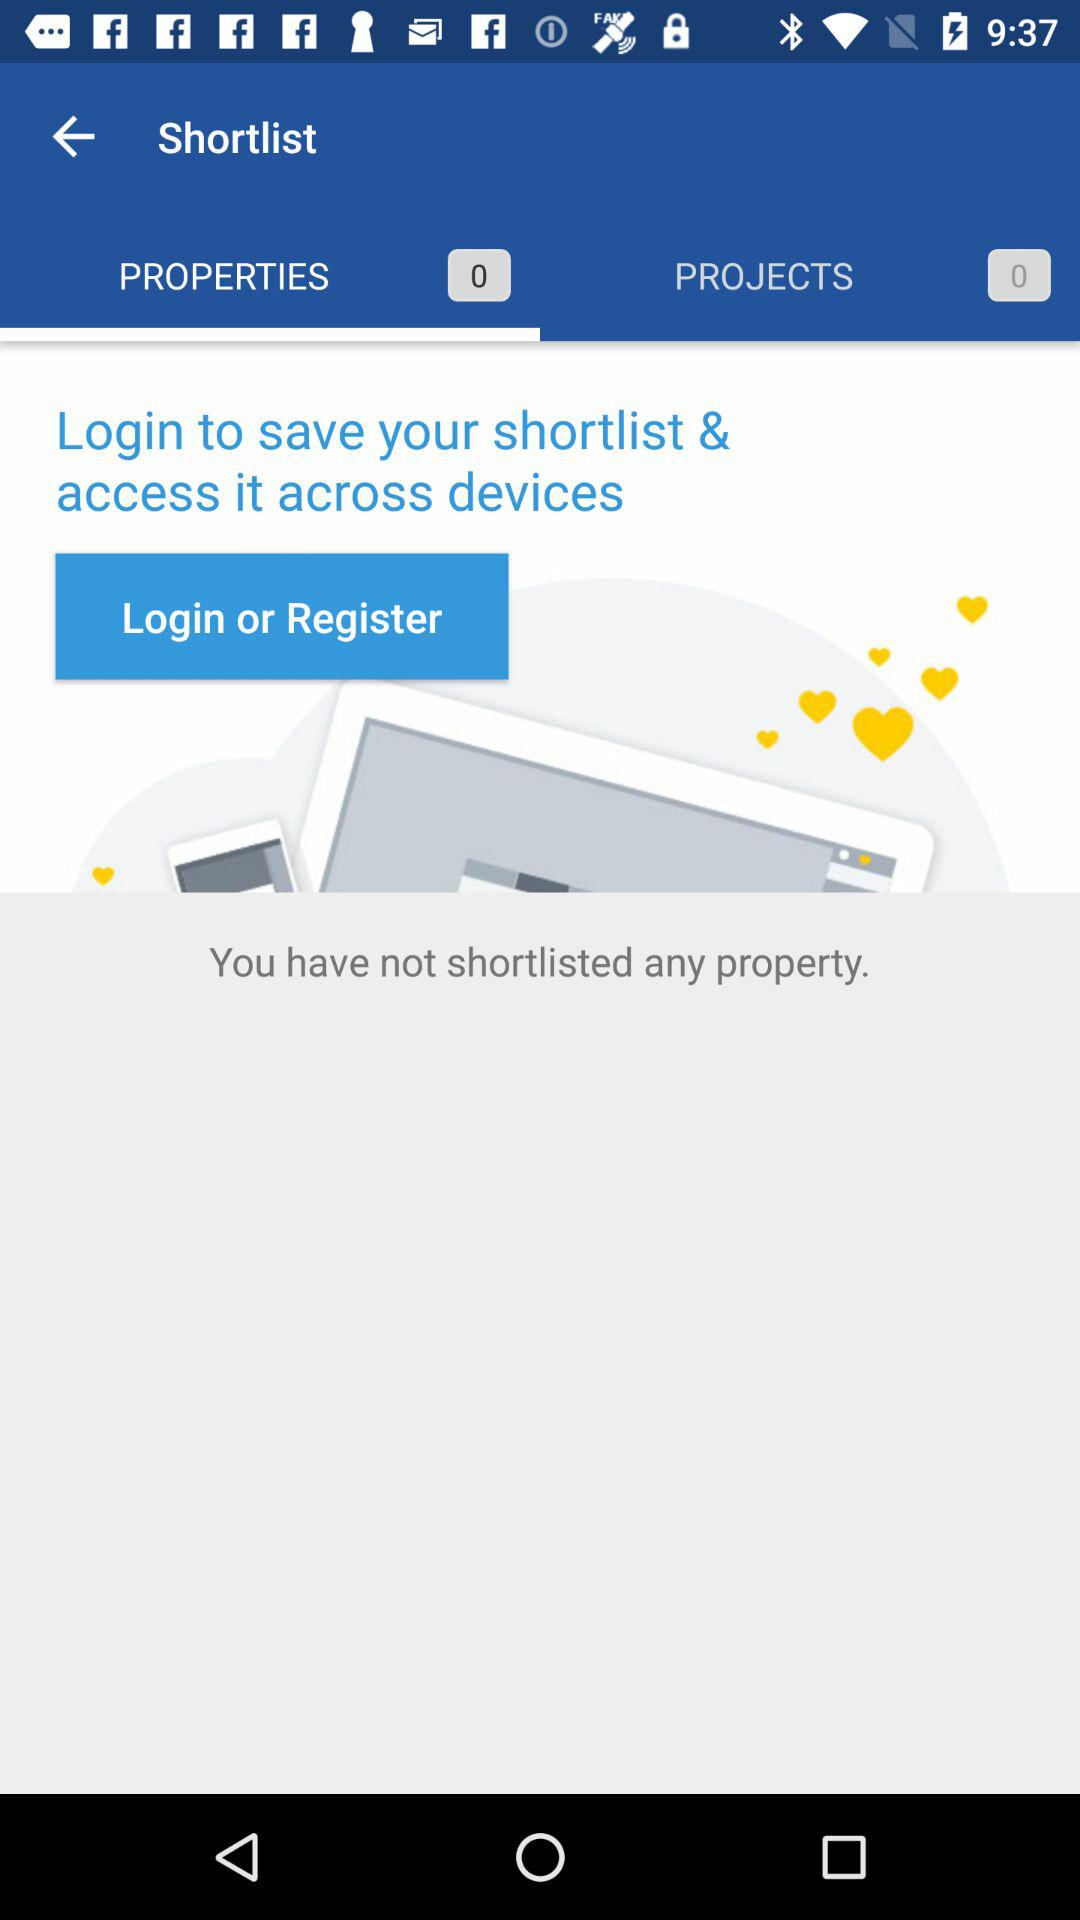What is the number of properties that have been shortlisted? The number of properties that have been shortlisted is 0. 